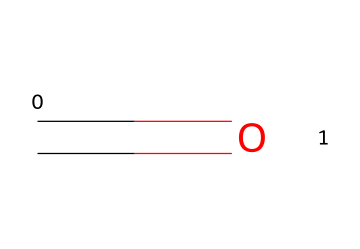What is the molecular formula of formaldehyde? The molecular formula is determined by counting the number of each type of atom present in the structure. The SMILES representation shows one carbon (C) and one oxygen (O) atom, which indicates the molecular formula of CH2O.
Answer: CH2O How many hydrogen atoms are in formaldehyde? The SMILES representation indicates that there are two hydrogen atoms bonded to the carbon atom (C). Thus, the count of hydrogen atoms is two.
Answer: 2 What type of bond is present in formaldehyde? In the SMILES representation, the '=' indicates a double bond between the carbon (C) and oxygen (O) atom. This signature shows that a double bond is present in the chemical structure.
Answer: double bond Is formaldehyde a polar molecule? To determine polarity, one should consider the electronegativity difference between the atoms and the molecular geometry. The presence of a carbonyl group (C=O) suggests that this molecule is polar due to the asymmetrical distribution of charge.
Answer: yes What is the primary health risk associated with formaldehyde exposure? Formaldehyde is known to be a toxic chemical, primarily causing respiratory issues and irritation. The most well-documented health risk from exposure is the potential to cause cancer.
Answer: cancer What functional group is represented by the C=O bond in formaldehyde? The C=O bond indicates the presence of a carbonyl functional group. This group characterizes many organic compounds, including aldehydes and ketones, and is essential in formaldehyde's classification.
Answer: carbonyl How does the structure of formaldehyde contribute to its use in construction materials? The small size of the formaldehyde molecule allows it to permeate materials easily, enabling better bonding and preservation properties in construction products. Additionally, its reactive nature contributes to various applications in adhesives and coatings.
Answer: reactive nature 